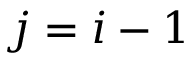<formula> <loc_0><loc_0><loc_500><loc_500>j = i - 1</formula> 